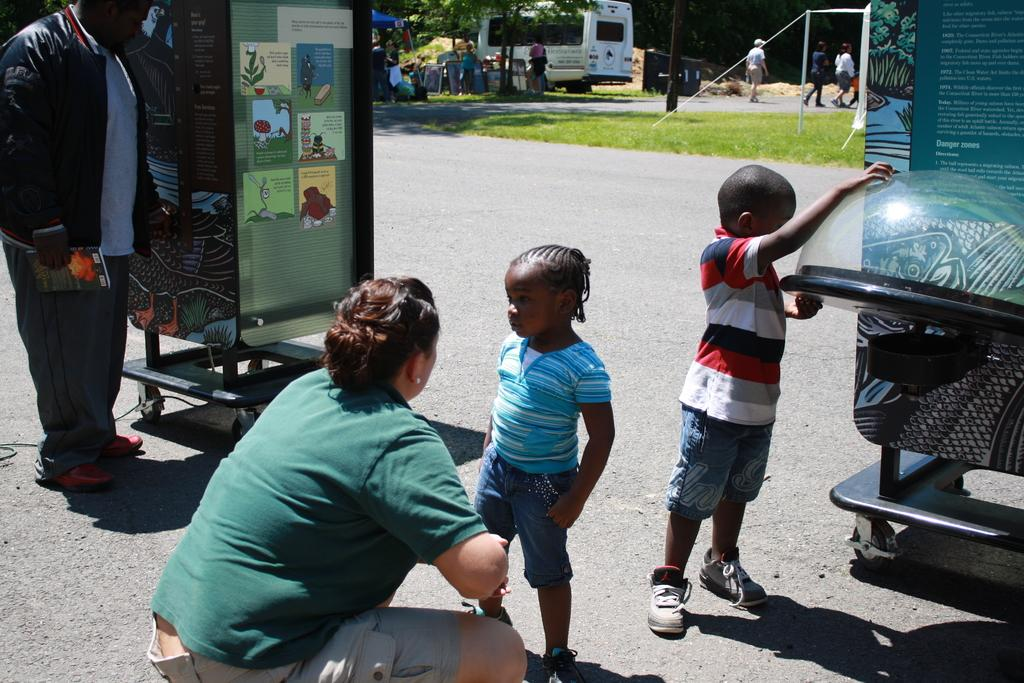What can be seen on the road in the image? There are kids on the road in the image. Are there any other people visible besides the kids? Yes, there are other people in the image. What can be found in the image besides people? There are stands in the image. What is visible in the background of the image? In the background of the image, there are people and vans, as well as trees. What type of guitar is the kid playing in the image? There is no guitar present in the image; the kids are on the road and there are other people and stands visible. 